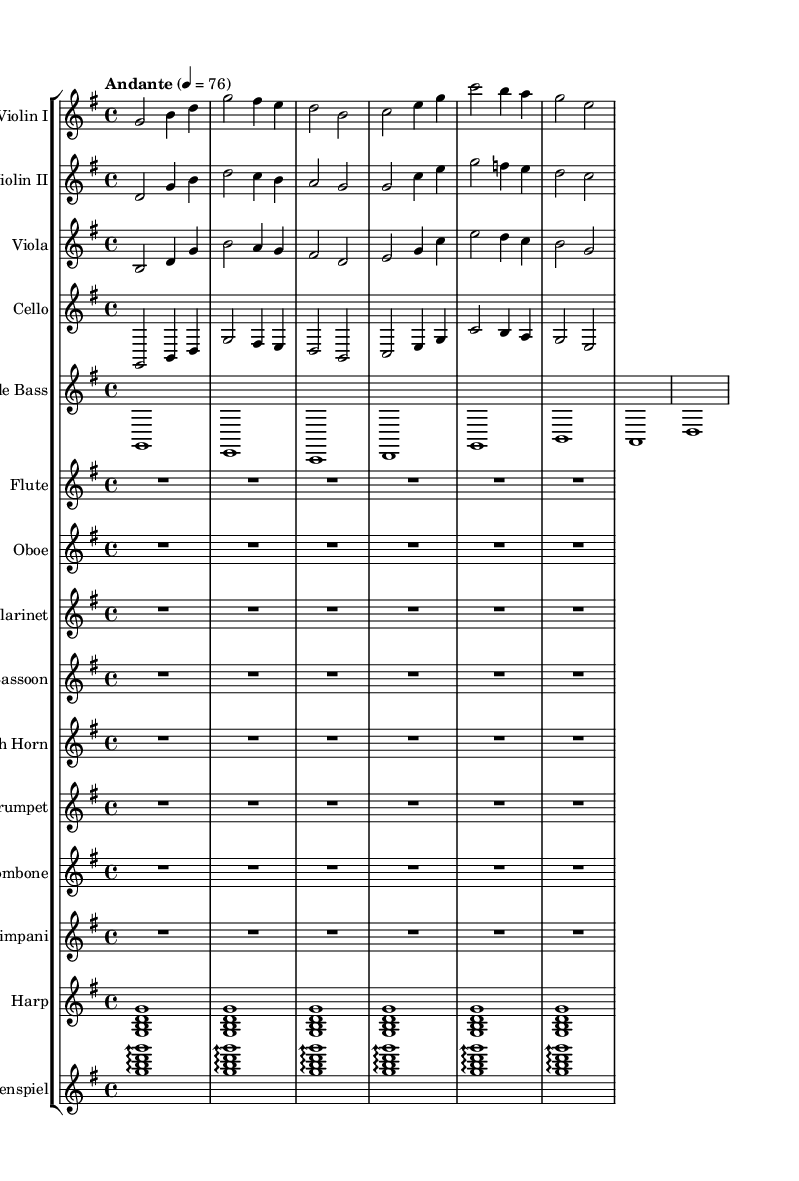What is the key signature of this music? The key signature indicated in the global section shows that it is G major, which has one sharp (F#).
Answer: G major What is the time signature of this composition? The time signature is noted in the global section and shows a 4/4 signature, meaning there are four beats in a measure.
Answer: 4/4 What is the tempo marking for the piece? The tempo marking in the global section states "Andante" with a metronome marking of 76, indicating a moderately slow tempo.
Answer: Andante, 76 How many instruments are being used in this piece? By counting the separate staves, there are 14 distinct instrumental parts represented in the score.
Answer: 14 What is the rhythmic structure of the first measure for Violin I? The first measure contains two half notes and two quarter notes, totaling four beats which adhere to the 4/4 time signature.
Answer: 2 half notes, 2 quarter notes Which instruments have rest measures indicated? The flute, oboe, clarinet, bassoon, french horn, trumpet, trombone, timpani, harp, and glockenspiel all show rest measures indicated through a rest notation worth 6 beats.
Answer: Flute, Oboe, Clarinet, Bassoon, French Horn, Trumpet, Trombone, Timpani, Harp, Glockenspiel How does the cello line in the sheet music relate to the violin lines? The cello shares similar rhythmic and melodiс phrasing with Violin I, maintaining harmonic support while complementing its melodic content, indicating an interdependent relationship between the two parts.
Answer: Interdependent relationship with Violin I 